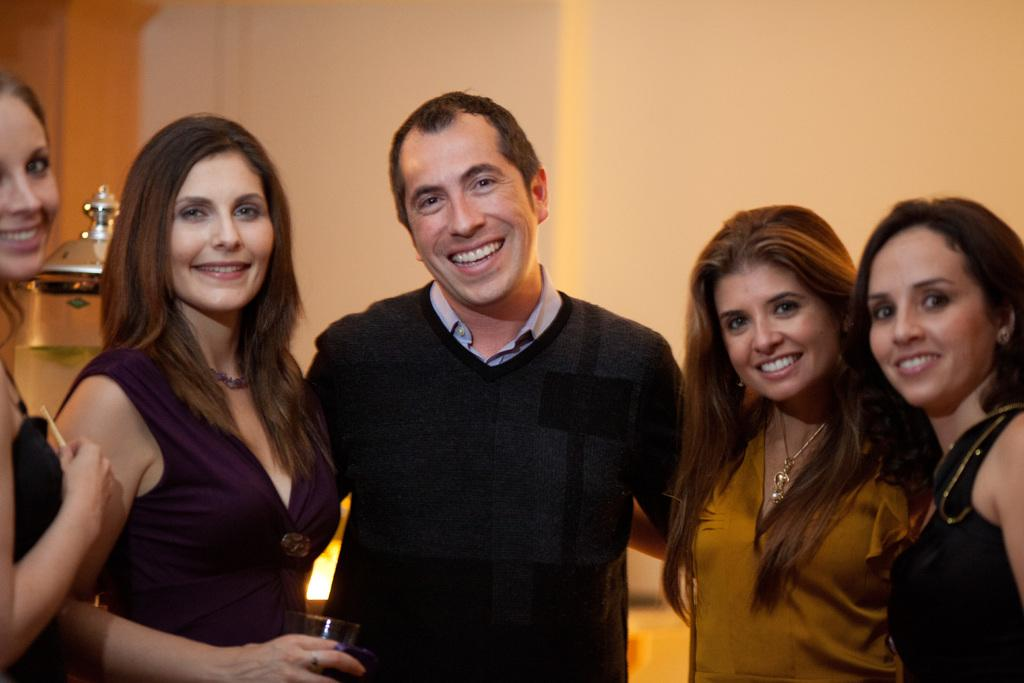Who is the main subject in the center of the image? There is a man standing in the center of the image. What is the man's facial expression? The man is smiling. How many women are in the image? There are four women in the image. What is the facial expression of the women? The women are smiling. What can be seen in the image that is used for holding liquids? There is a glass visible in the image. What is the object in the image? The object in the image is not specified, but it is mentioned that there is one. What can be seen in the background of the image? There is a wall in the background of the image. What type of stocking is the man wearing in the image? There is no mention of stockings in the image, so it cannot be determined if the man is wearing any. 